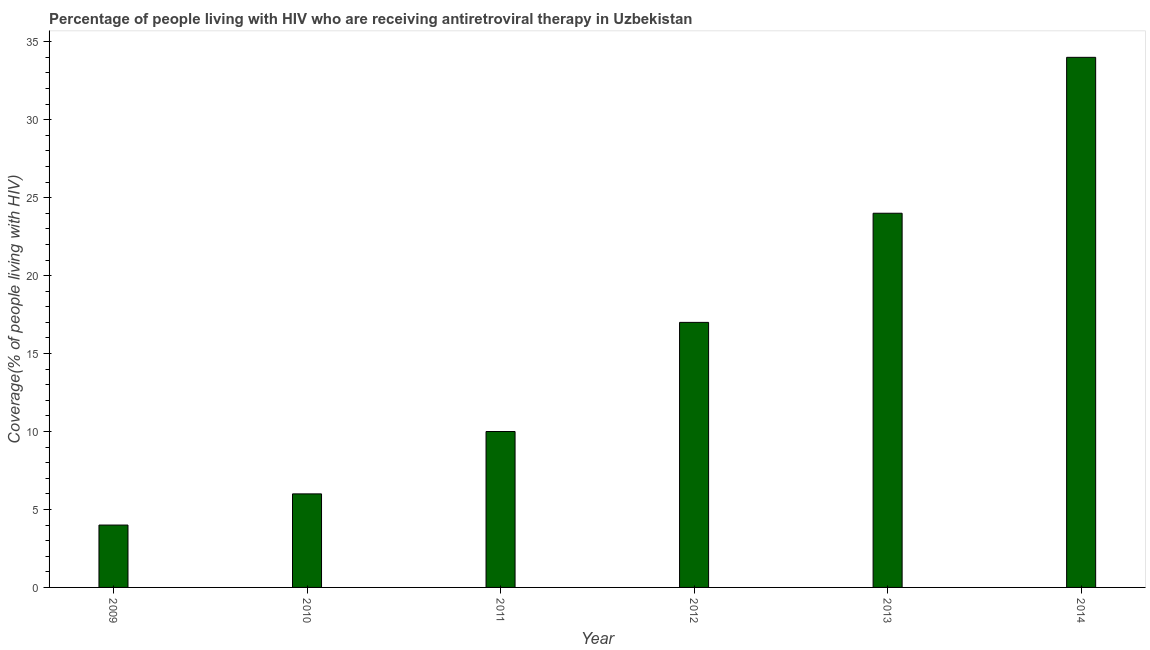Does the graph contain any zero values?
Keep it short and to the point. No. Does the graph contain grids?
Offer a terse response. No. What is the title of the graph?
Offer a very short reply. Percentage of people living with HIV who are receiving antiretroviral therapy in Uzbekistan. What is the label or title of the X-axis?
Your answer should be very brief. Year. What is the label or title of the Y-axis?
Keep it short and to the point. Coverage(% of people living with HIV). What is the antiretroviral therapy coverage in 2012?
Your answer should be very brief. 17. Across all years, what is the maximum antiretroviral therapy coverage?
Provide a succinct answer. 34. Across all years, what is the minimum antiretroviral therapy coverage?
Your response must be concise. 4. In which year was the antiretroviral therapy coverage minimum?
Give a very brief answer. 2009. What is the sum of the antiretroviral therapy coverage?
Ensure brevity in your answer.  95. What is the median antiretroviral therapy coverage?
Offer a terse response. 13.5. In how many years, is the antiretroviral therapy coverage greater than 16 %?
Keep it short and to the point. 3. What is the ratio of the antiretroviral therapy coverage in 2009 to that in 2010?
Offer a terse response. 0.67. What is the difference between the highest and the second highest antiretroviral therapy coverage?
Offer a terse response. 10. Is the sum of the antiretroviral therapy coverage in 2012 and 2014 greater than the maximum antiretroviral therapy coverage across all years?
Ensure brevity in your answer.  Yes. In how many years, is the antiretroviral therapy coverage greater than the average antiretroviral therapy coverage taken over all years?
Give a very brief answer. 3. How many bars are there?
Provide a short and direct response. 6. How many years are there in the graph?
Your answer should be compact. 6. What is the difference between two consecutive major ticks on the Y-axis?
Make the answer very short. 5. What is the Coverage(% of people living with HIV) in 2009?
Provide a short and direct response. 4. What is the Coverage(% of people living with HIV) of 2011?
Offer a very short reply. 10. What is the Coverage(% of people living with HIV) of 2013?
Keep it short and to the point. 24. What is the Coverage(% of people living with HIV) in 2014?
Your answer should be compact. 34. What is the difference between the Coverage(% of people living with HIV) in 2010 and 2012?
Offer a very short reply. -11. What is the difference between the Coverage(% of people living with HIV) in 2011 and 2014?
Your answer should be compact. -24. What is the difference between the Coverage(% of people living with HIV) in 2012 and 2013?
Keep it short and to the point. -7. What is the difference between the Coverage(% of people living with HIV) in 2012 and 2014?
Ensure brevity in your answer.  -17. What is the difference between the Coverage(% of people living with HIV) in 2013 and 2014?
Offer a terse response. -10. What is the ratio of the Coverage(% of people living with HIV) in 2009 to that in 2010?
Your answer should be very brief. 0.67. What is the ratio of the Coverage(% of people living with HIV) in 2009 to that in 2012?
Ensure brevity in your answer.  0.23. What is the ratio of the Coverage(% of people living with HIV) in 2009 to that in 2013?
Keep it short and to the point. 0.17. What is the ratio of the Coverage(% of people living with HIV) in 2009 to that in 2014?
Make the answer very short. 0.12. What is the ratio of the Coverage(% of people living with HIV) in 2010 to that in 2011?
Provide a succinct answer. 0.6. What is the ratio of the Coverage(% of people living with HIV) in 2010 to that in 2012?
Your answer should be very brief. 0.35. What is the ratio of the Coverage(% of people living with HIV) in 2010 to that in 2014?
Your answer should be compact. 0.18. What is the ratio of the Coverage(% of people living with HIV) in 2011 to that in 2012?
Your answer should be compact. 0.59. What is the ratio of the Coverage(% of people living with HIV) in 2011 to that in 2013?
Give a very brief answer. 0.42. What is the ratio of the Coverage(% of people living with HIV) in 2011 to that in 2014?
Offer a terse response. 0.29. What is the ratio of the Coverage(% of people living with HIV) in 2012 to that in 2013?
Make the answer very short. 0.71. What is the ratio of the Coverage(% of people living with HIV) in 2012 to that in 2014?
Make the answer very short. 0.5. What is the ratio of the Coverage(% of people living with HIV) in 2013 to that in 2014?
Your answer should be very brief. 0.71. 